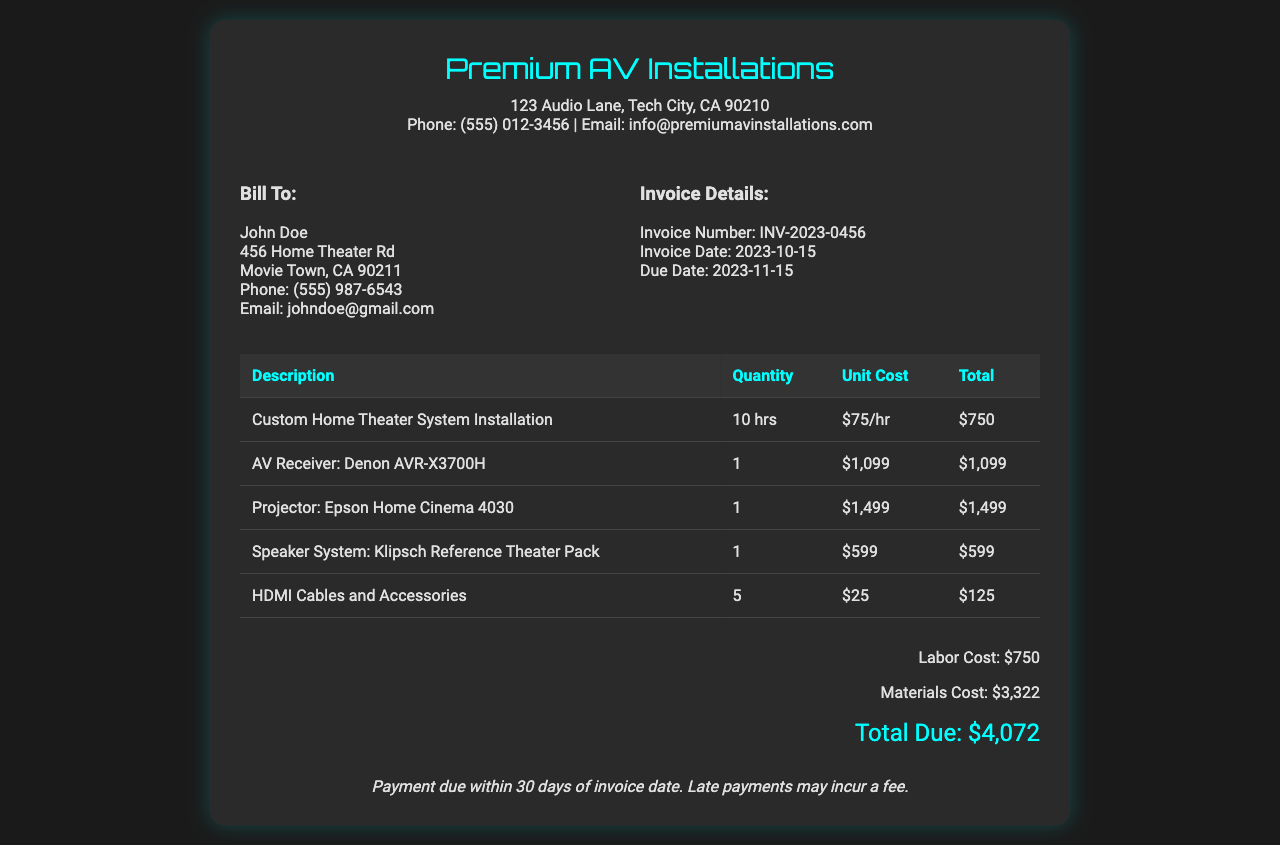What is the invoice number? The invoice number is a unique identifier assigned to this transaction.
Answer: INV-2023-0456 What is the total labor cost? The total labor cost is specified in the document as the sum of the hours worked multiplied by the hourly rate.
Answer: $750 What is the due date for the invoice? The due date indicates when payment must be made, as stated in the document.
Answer: 2023-11-15 How many hours were billed for installation? The total hours billed for installation are shown in the description of the labor costs.
Answer: 10 hrs What is the name of the AV receiver installed? The name of the installed AV receiver is mentioned under the materials used.
Answer: Denon AVR-X3700H What is the total amount due? The total amount due is the final calculated balance at the end of the invoice.
Answer: $4,072 What is the address of the company? The address provided in the document specifies the location of the service provider.
Answer: 123 Audio Lane, Tech City, CA 90210 What is the payment term for this invoice? The payment term outlines the conditions under which payment is expected for the services rendered.
Answer: Payment due within 30 days of invoice date What is the cost of the HDMI cables and accessories? The cost for HDMI cables and accessories is noted alongside the item on the invoice.
Answer: $125 